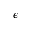<formula> <loc_0><loc_0><loc_500><loc_500>\epsilon</formula> 